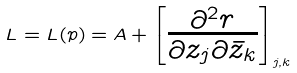<formula> <loc_0><loc_0><loc_500><loc_500>L = L ( p ) = A + \begin{bmatrix} \frac { \partial ^ { 2 } r } { \partial z _ { j } \partial \bar { z } _ { k } } \end{bmatrix} _ { j , k }</formula> 